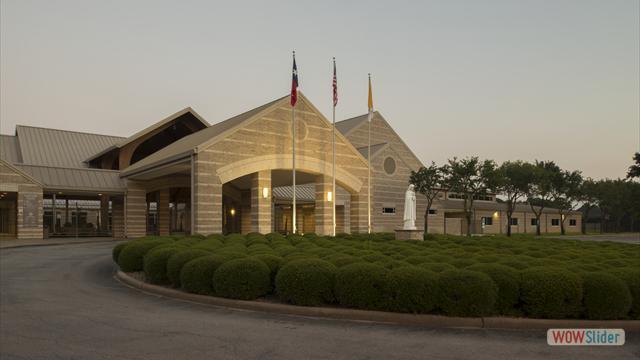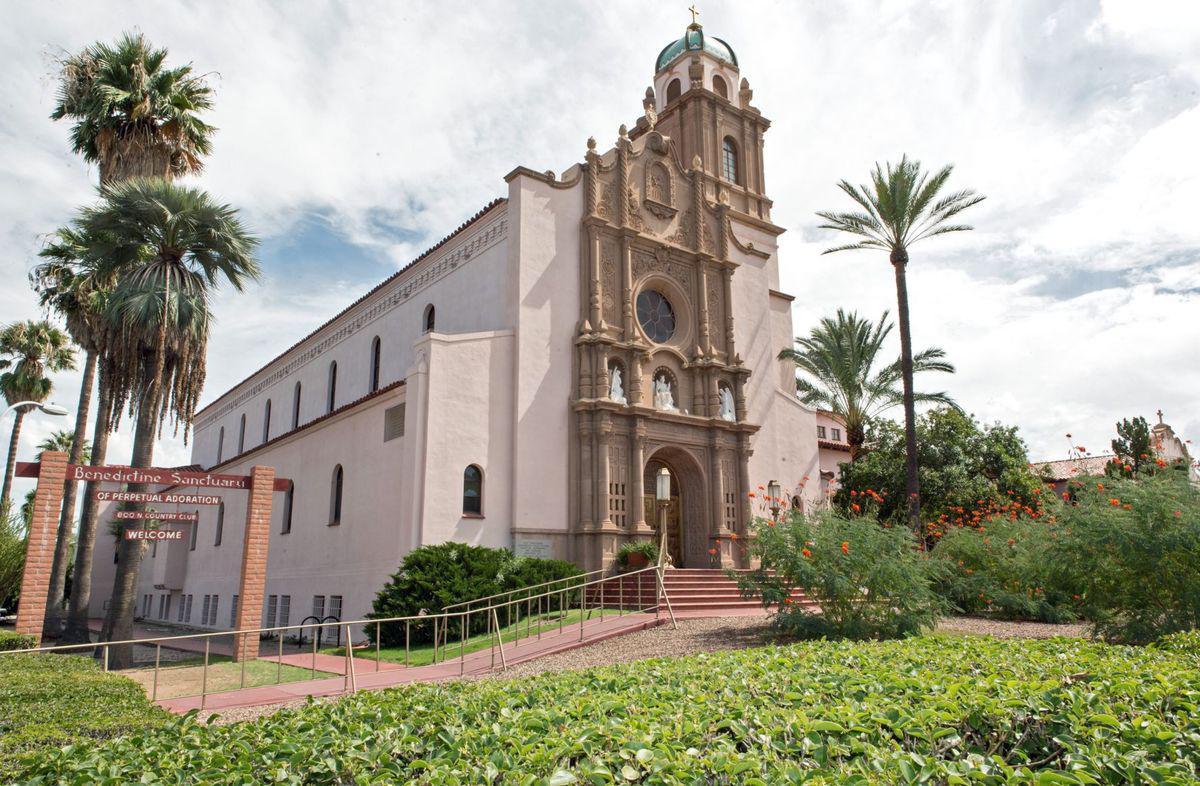The first image is the image on the left, the second image is the image on the right. Considering the images on both sides, is "There is at least one visible cross atop the building in one of the images." valid? Answer yes or no. Yes. The first image is the image on the left, the second image is the image on the right. Analyze the images presented: Is the assertion "There is at least one cross atop the building in one of the images." valid? Answer yes or no. Yes. 